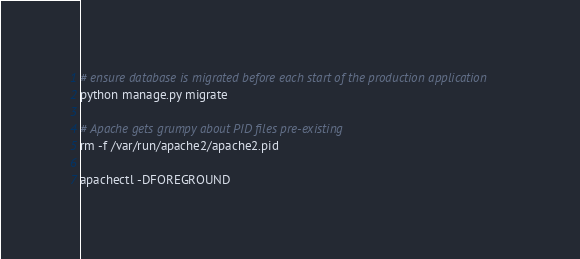<code> <loc_0><loc_0><loc_500><loc_500><_Bash_># ensure database is migrated before each start of the production application
python manage.py migrate

# Apache gets grumpy about PID files pre-existing
rm -f /var/run/apache2/apache2.pid

apachectl -DFOREGROUND
</code> 